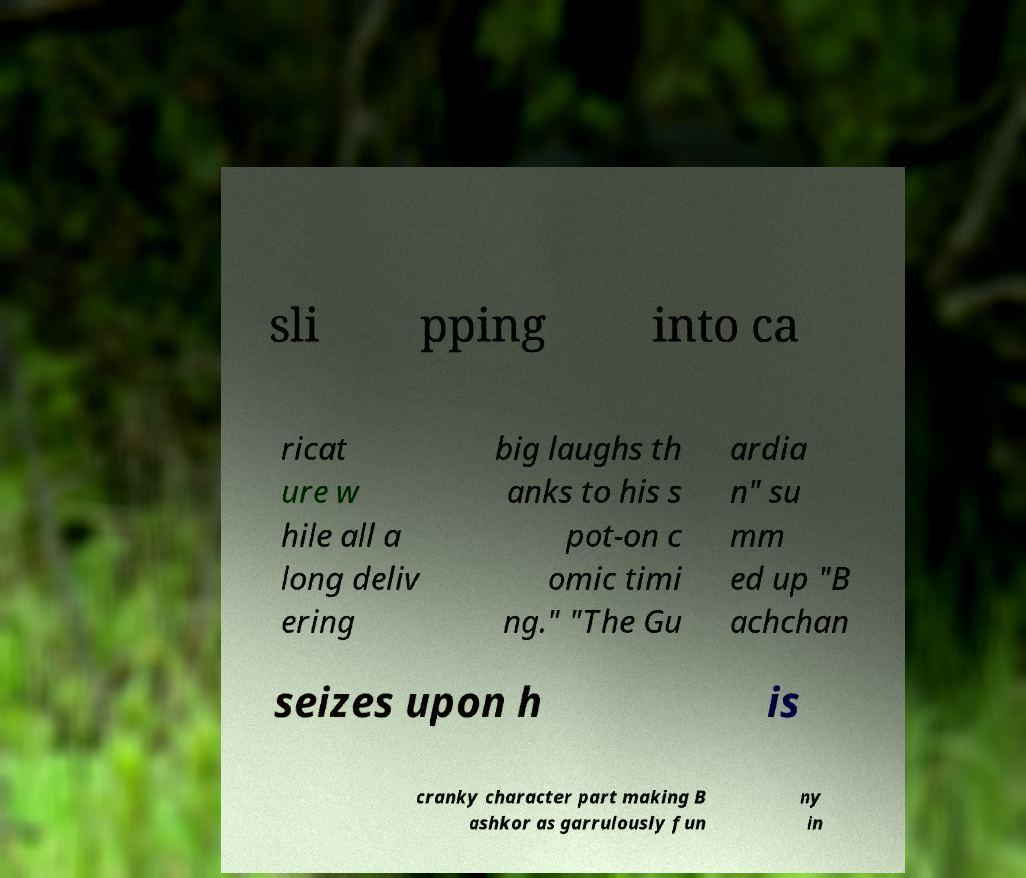Can you read and provide the text displayed in the image?This photo seems to have some interesting text. Can you extract and type it out for me? sli pping into ca ricat ure w hile all a long deliv ering big laughs th anks to his s pot-on c omic timi ng." "The Gu ardia n" su mm ed up "B achchan seizes upon h is cranky character part making B ashkor as garrulously fun ny in 